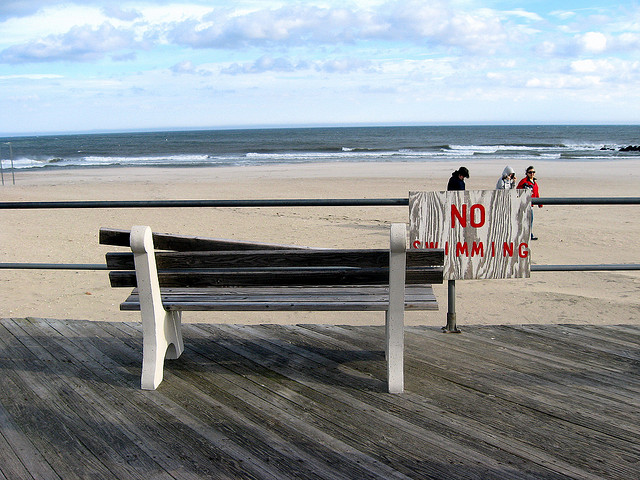Identify the text contained in this image. NO SWIMMING 